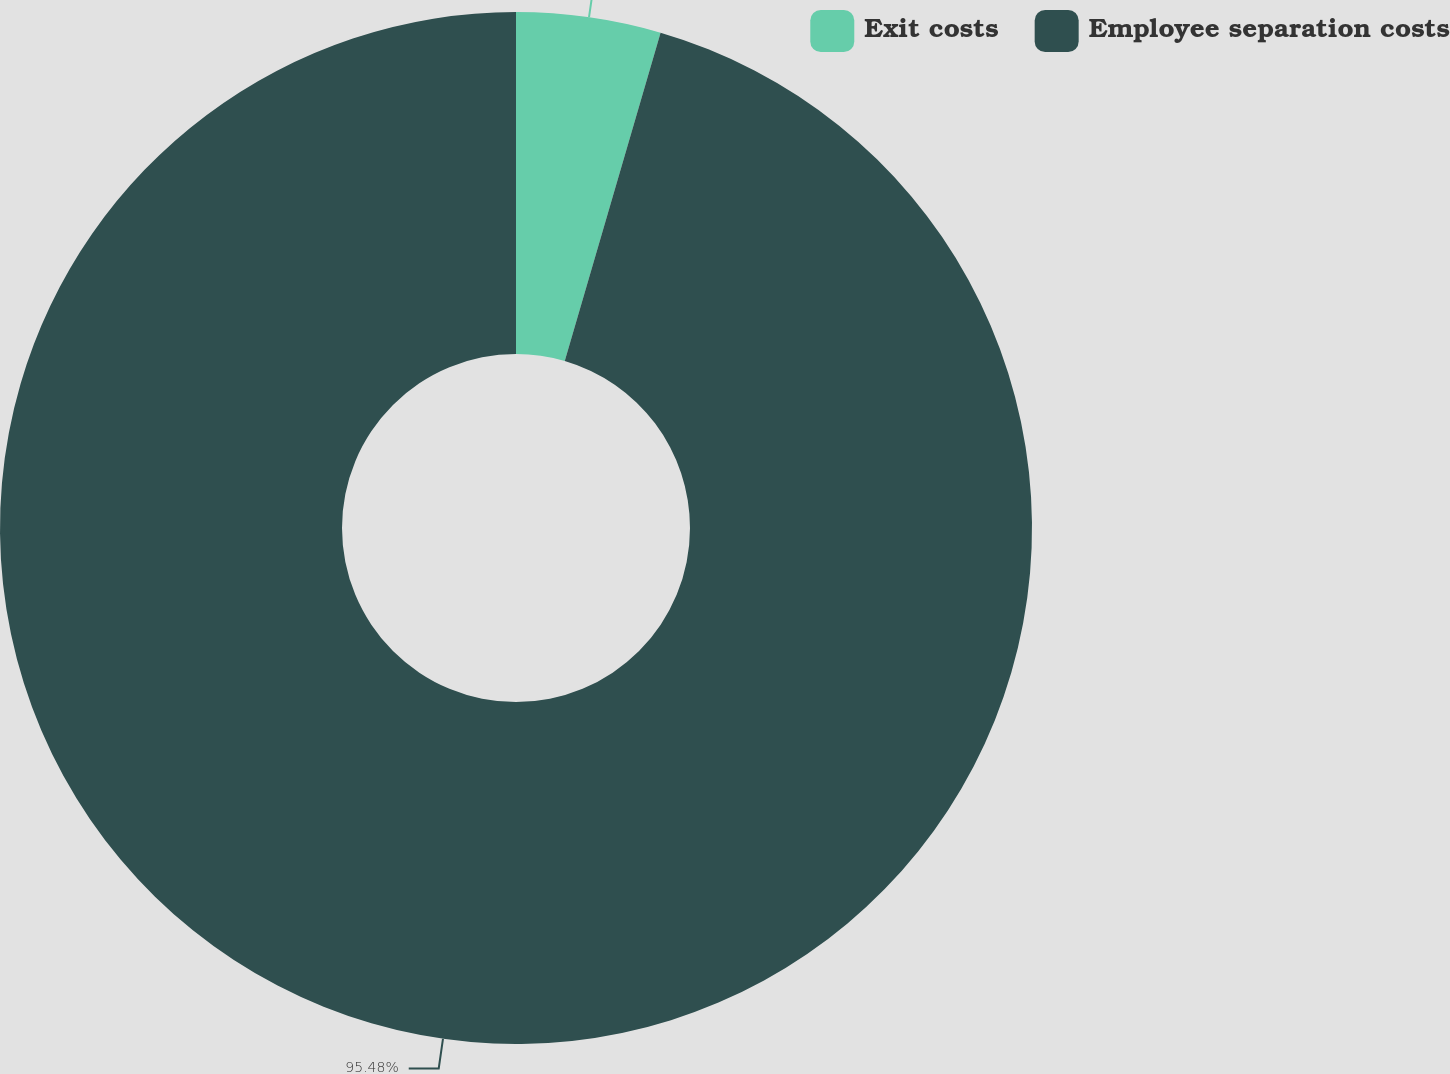<chart> <loc_0><loc_0><loc_500><loc_500><pie_chart><fcel>Exit costs<fcel>Employee separation costs<nl><fcel>4.52%<fcel>95.48%<nl></chart> 